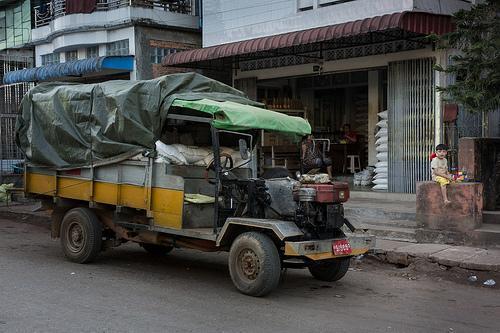How many boys?
Give a very brief answer. 1. 